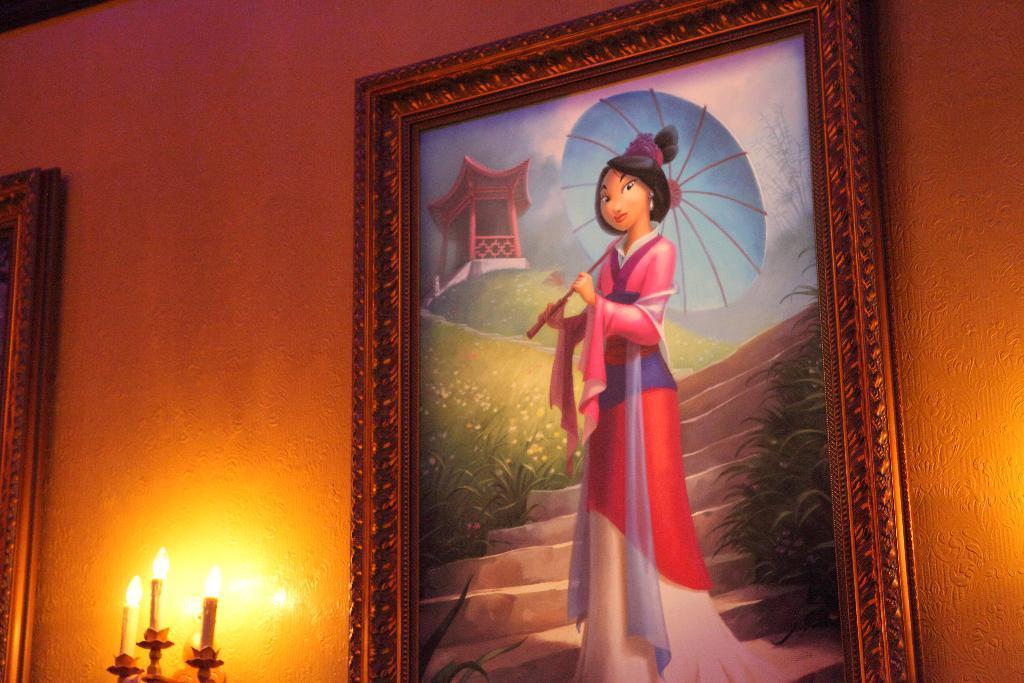Could you give a brief overview of what you see in this image? There is a wall. On the wall there are photo frames. Also there are candles with lights. On the photo frame there is a painting of a lady holding umbrella, plants and steps. 